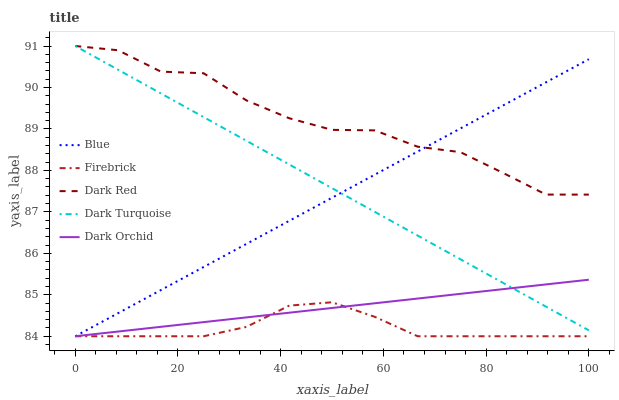Does Firebrick have the minimum area under the curve?
Answer yes or no. Yes. Does Dark Red have the maximum area under the curve?
Answer yes or no. Yes. Does Dark Red have the minimum area under the curve?
Answer yes or no. No. Does Firebrick have the maximum area under the curve?
Answer yes or no. No. Is Blue the smoothest?
Answer yes or no. Yes. Is Dark Red the roughest?
Answer yes or no. Yes. Is Firebrick the smoothest?
Answer yes or no. No. Is Firebrick the roughest?
Answer yes or no. No. Does Dark Red have the lowest value?
Answer yes or no. No. Does Dark Turquoise have the highest value?
Answer yes or no. Yes. Does Firebrick have the highest value?
Answer yes or no. No. Is Dark Orchid less than Dark Red?
Answer yes or no. Yes. Is Dark Turquoise greater than Firebrick?
Answer yes or no. Yes. Does Dark Orchid intersect Firebrick?
Answer yes or no. Yes. Is Dark Orchid less than Firebrick?
Answer yes or no. No. Is Dark Orchid greater than Firebrick?
Answer yes or no. No. Does Dark Orchid intersect Dark Red?
Answer yes or no. No. 